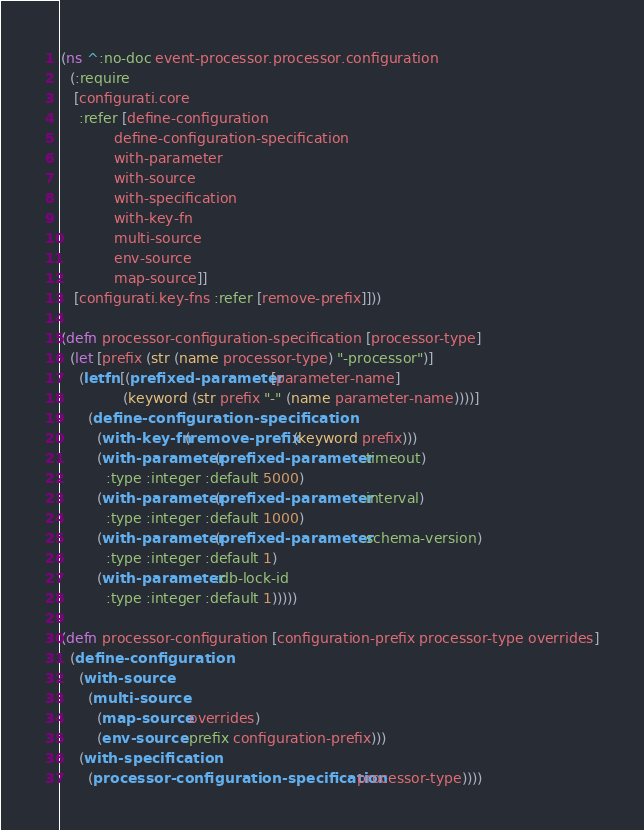Convert code to text. <code><loc_0><loc_0><loc_500><loc_500><_Clojure_>(ns ^:no-doc event-processor.processor.configuration
  (:require
   [configurati.core
    :refer [define-configuration
            define-configuration-specification
            with-parameter
            with-source
            with-specification
            with-key-fn
            multi-source
            env-source
            map-source]]
   [configurati.key-fns :refer [remove-prefix]]))

(defn processor-configuration-specification [processor-type]
  (let [prefix (str (name processor-type) "-processor")]
    (letfn [(prefixed-parameter [parameter-name]
              (keyword (str prefix "-" (name parameter-name))))]
      (define-configuration-specification
        (with-key-fn (remove-prefix (keyword prefix)))
        (with-parameter (prefixed-parameter :timeout)
          :type :integer :default 5000)
        (with-parameter (prefixed-parameter :interval)
          :type :integer :default 1000)
        (with-parameter (prefixed-parameter :schema-version)
          :type :integer :default 1)
        (with-parameter :db-lock-id
          :type :integer :default 1)))))

(defn processor-configuration [configuration-prefix processor-type overrides]
  (define-configuration
    (with-source
      (multi-source
        (map-source overrides)
        (env-source :prefix configuration-prefix)))
    (with-specification
      (processor-configuration-specification processor-type))))
</code> 